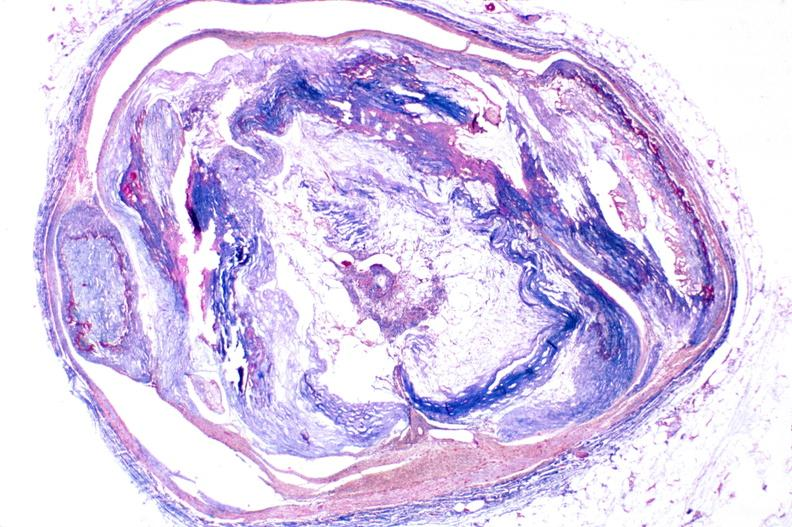what does this image show?
Answer the question using a single word or phrase. Atherosclerosis 